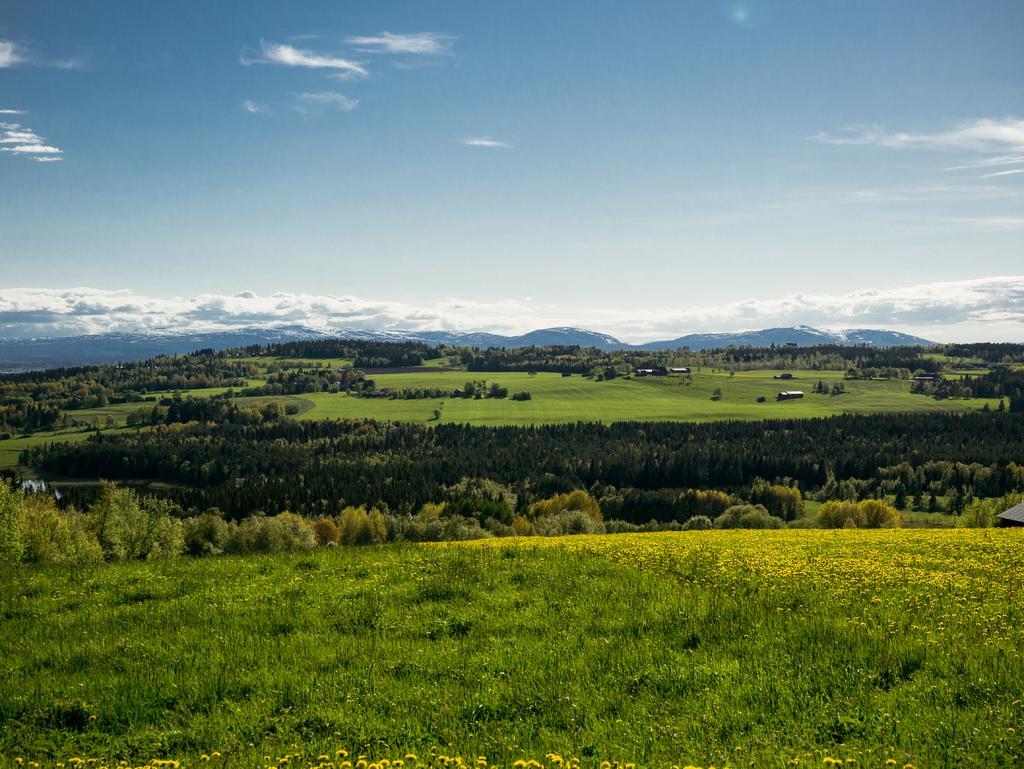Could you give a brief overview of what you see in this image? Sky is in blue color. Here we can see grass, trees and plants. 